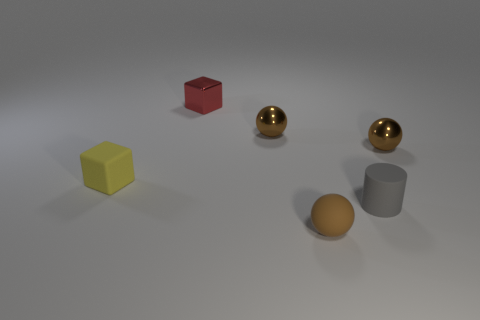What number of yellow objects are the same shape as the red metallic thing?
Keep it short and to the point. 1. How many spheres are there?
Make the answer very short. 3. Is the shape of the small red object the same as the small matte thing that is on the left side of the metal cube?
Make the answer very short. Yes. What number of objects are tiny balls or matte things to the right of the red object?
Keep it short and to the point. 4. There is another object that is the same shape as the small red object; what is its material?
Provide a short and direct response. Rubber. There is a object left of the red metallic object; is it the same shape as the brown matte thing?
Your answer should be compact. No. Is the number of rubber cylinders behind the small gray object less than the number of tiny rubber objects right of the rubber sphere?
Offer a terse response. Yes. How many other things are the same shape as the gray object?
Provide a short and direct response. 0. There is a brown object to the right of the gray cylinder that is to the right of the cube that is in front of the tiny red metallic cube; what size is it?
Make the answer very short. Small. How many gray objects are matte cylinders or tiny metal things?
Ensure brevity in your answer.  1. 